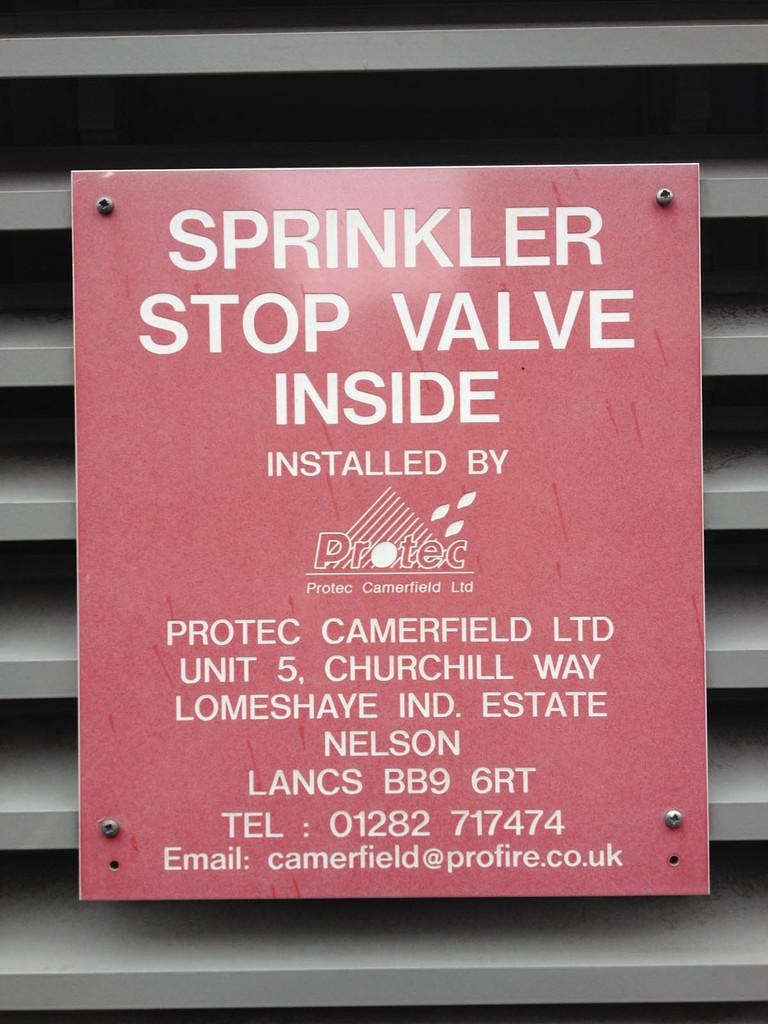Where will you find the sprinkler stop valve?
Your answer should be compact. Inside. 